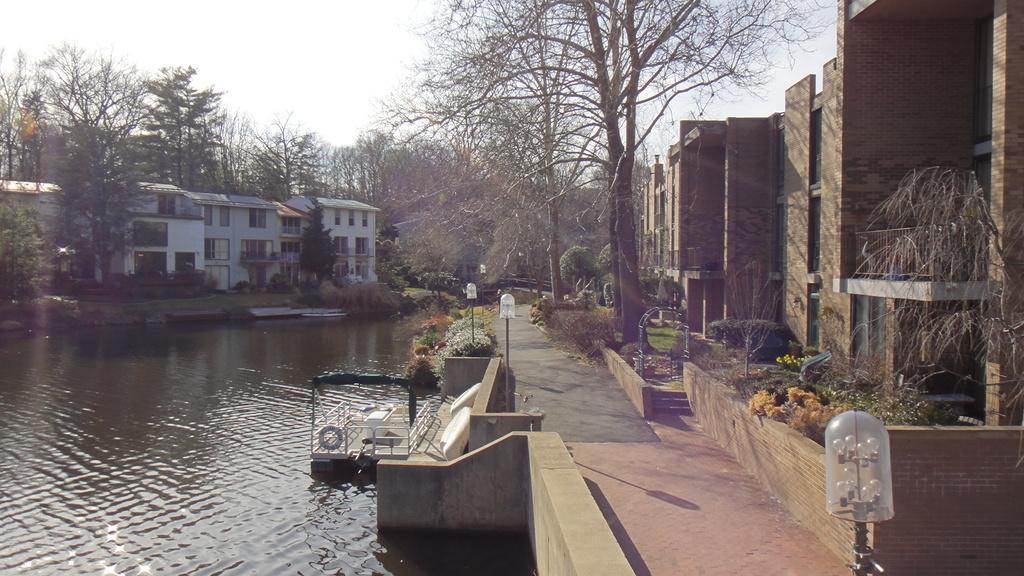Could you give a brief overview of what you see in this image? In this image there is a lake in the middle. On the lake there is a boat. There are buildings on either side of the lake. At the top there is sky. On the right side there are trees beside the buildings. On the road there are lights. 